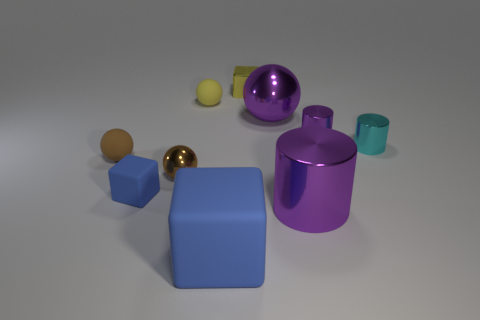What number of shiny objects are there?
Your response must be concise. 6. What number of other small things are the same shape as the small yellow shiny object?
Your answer should be very brief. 1. Is the large blue matte object the same shape as the yellow metallic thing?
Your answer should be very brief. Yes. The purple metallic ball is what size?
Your answer should be very brief. Large. How many brown rubber things are the same size as the yellow matte thing?
Offer a very short reply. 1. Is the size of the cube behind the purple ball the same as the purple cylinder in front of the small cyan object?
Your answer should be very brief. No. What is the shape of the large purple object that is in front of the small purple shiny thing?
Offer a very short reply. Cylinder. What material is the ball that is behind the big purple shiny thing behind the brown matte ball?
Give a very brief answer. Rubber. Are there any metallic cubes that have the same color as the small matte cube?
Your answer should be compact. No. Is the size of the yellow block the same as the metal ball that is in front of the purple ball?
Keep it short and to the point. Yes. 